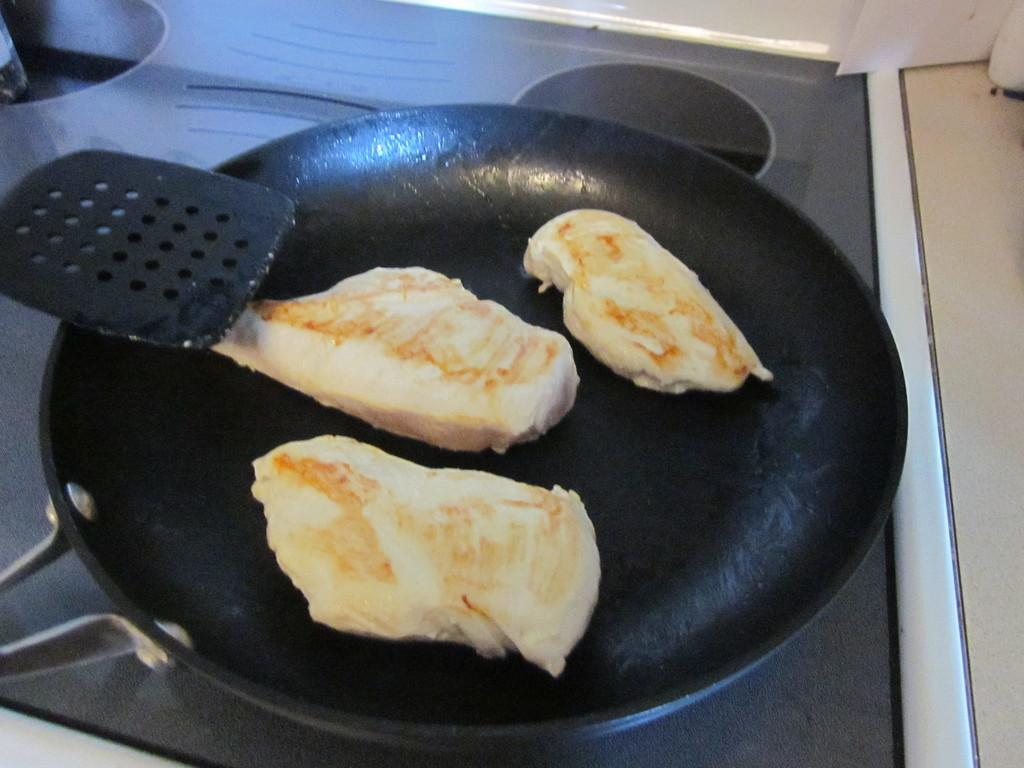What is on the pan in the image? There is food on a pan in the image. Where is the pan located? The pan is on a platform. What else can be seen on the platform? There are objects visible on the platform. How many roses are on the pan with the food in the image? There are no roses present in the image; it only shows food on a pan and objects on a platform. 